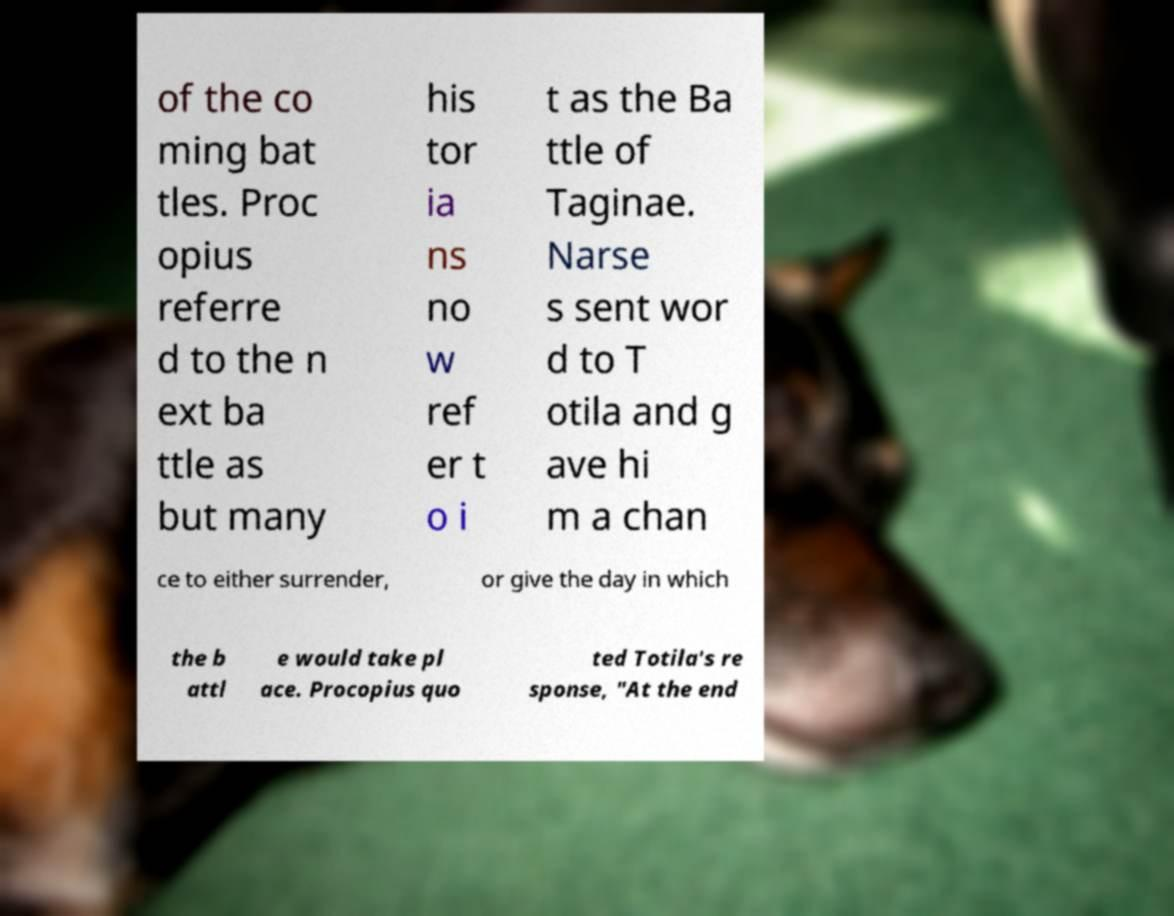Could you extract and type out the text from this image? of the co ming bat tles. Proc opius referre d to the n ext ba ttle as but many his tor ia ns no w ref er t o i t as the Ba ttle of Taginae. Narse s sent wor d to T otila and g ave hi m a chan ce to either surrender, or give the day in which the b attl e would take pl ace. Procopius quo ted Totila's re sponse, "At the end 